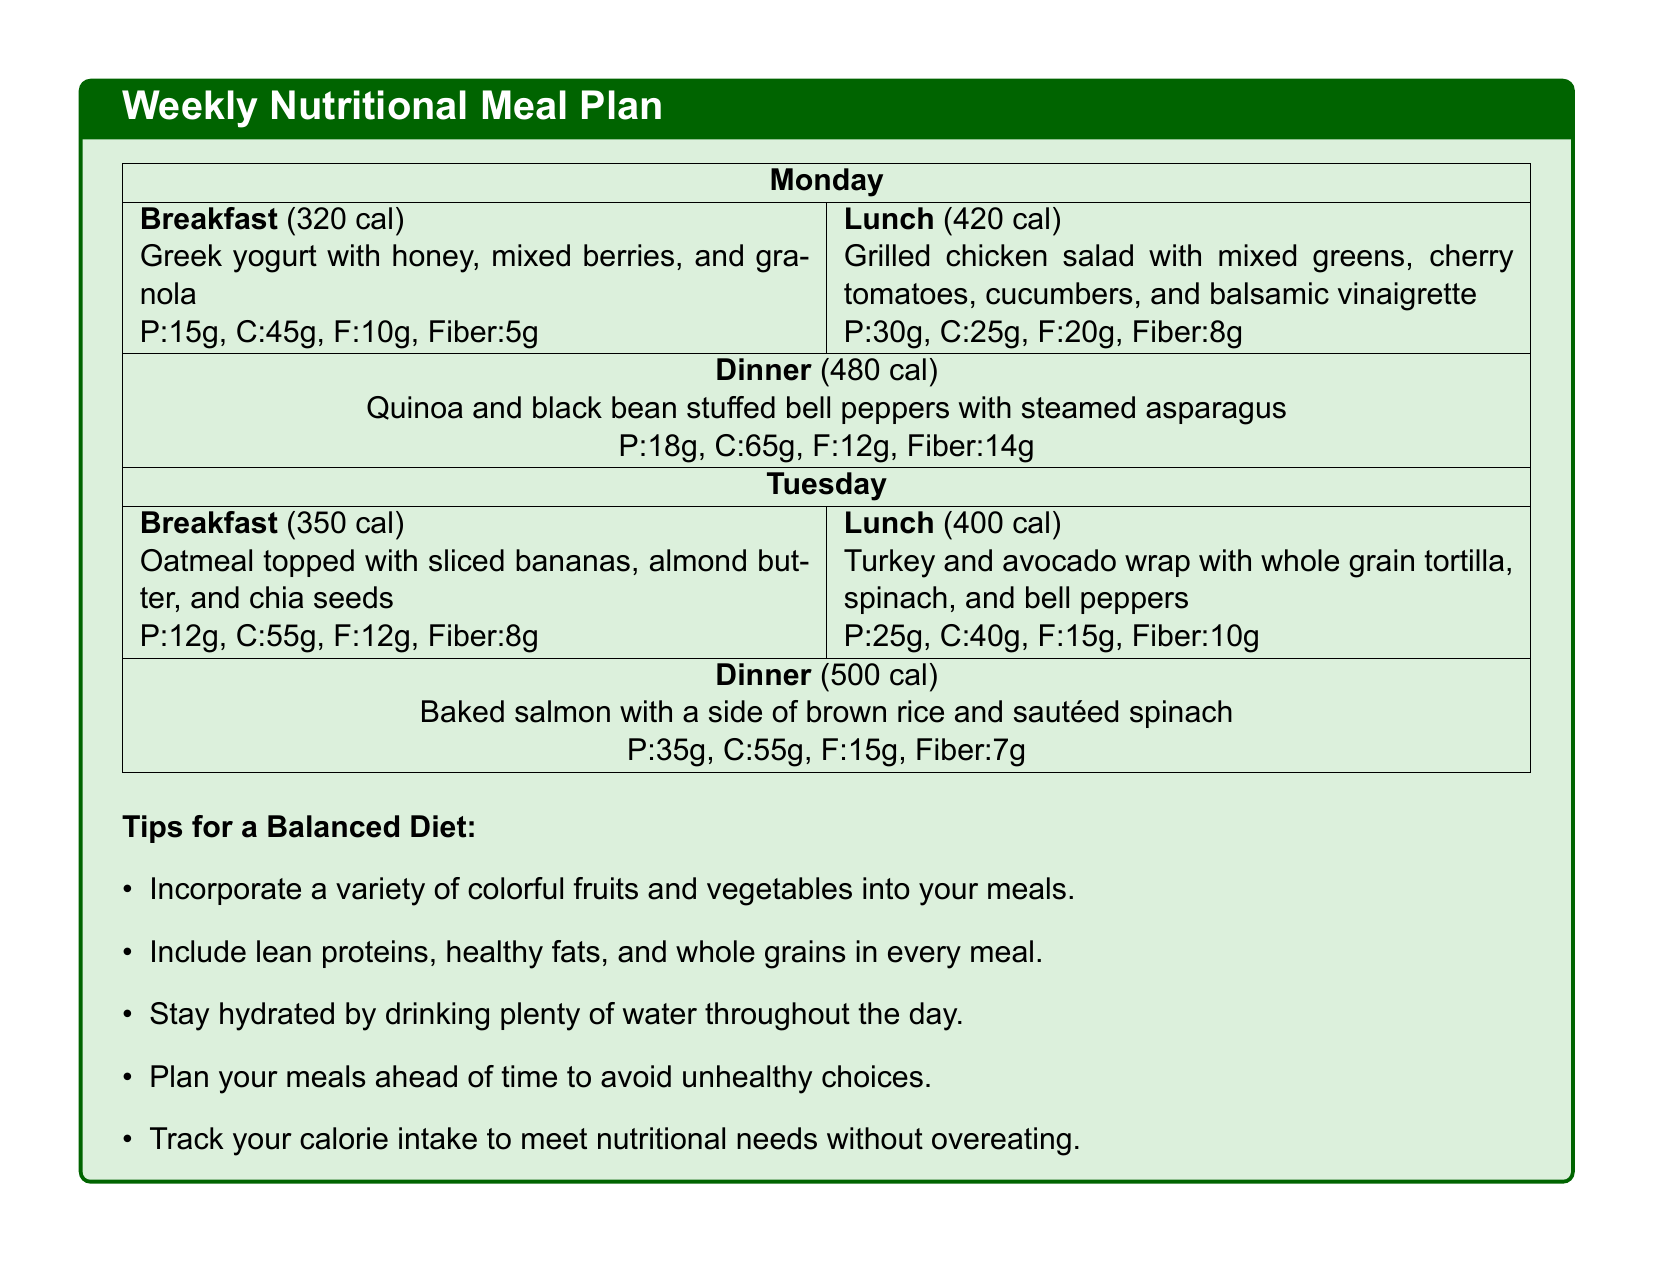What is the calorie count of breakfast on Monday? The breakfast for Monday has a specified calorie count of 320 calories.
Answer: 320 cal How many grams of protein does the Tuesday lunch provide? The protein content for the Tuesday lunch is listed as 25 grams.
Answer: 25g What vegetable is included in the dinner on Monday? The dinner on Monday features steamed asparagus as part of the meal.
Answer: asparagus What is the total calorie count for dinner on Tuesday? The dinner for Tuesday has a calorie count of 500 calories as shown in the meal plan.
Answer: 500 cal Which nutrient is highlighted for both Monday's meals as a source of fiber? Fiber content is provided for both breakfast and dinner on Monday, with specific grams listed.
Answer: Fiber What is a tip mentioned for maintaining a balanced diet? The meal plan includes several tips, among which staying hydrated is one.
Answer: Stay hydrated How many grams of carbohydrates are in the Monday lunch? The carbohydrates in the Monday lunch are noted to be 25 grams.
Answer: 25g What is served for lunch on Tuesday? The lunch on Tuesday features a turkey and avocado wrap with various ingredients.
Answer: Turkey and avocado wrap What is the total protein in the dinner for both Monday and Tuesday? The protein for Monday dinner is 18g and for Tuesday dinner is 35g, totaling 53g.
Answer: 53g 